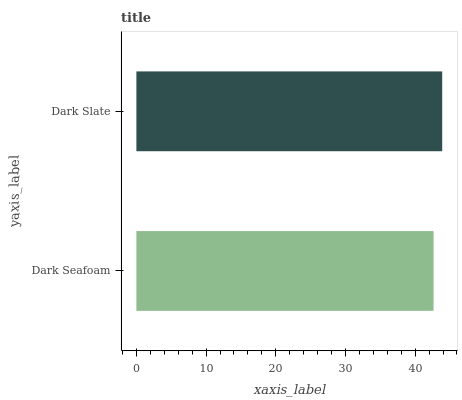Is Dark Seafoam the minimum?
Answer yes or no. Yes. Is Dark Slate the maximum?
Answer yes or no. Yes. Is Dark Slate the minimum?
Answer yes or no. No. Is Dark Slate greater than Dark Seafoam?
Answer yes or no. Yes. Is Dark Seafoam less than Dark Slate?
Answer yes or no. Yes. Is Dark Seafoam greater than Dark Slate?
Answer yes or no. No. Is Dark Slate less than Dark Seafoam?
Answer yes or no. No. Is Dark Slate the high median?
Answer yes or no. Yes. Is Dark Seafoam the low median?
Answer yes or no. Yes. Is Dark Seafoam the high median?
Answer yes or no. No. Is Dark Slate the low median?
Answer yes or no. No. 